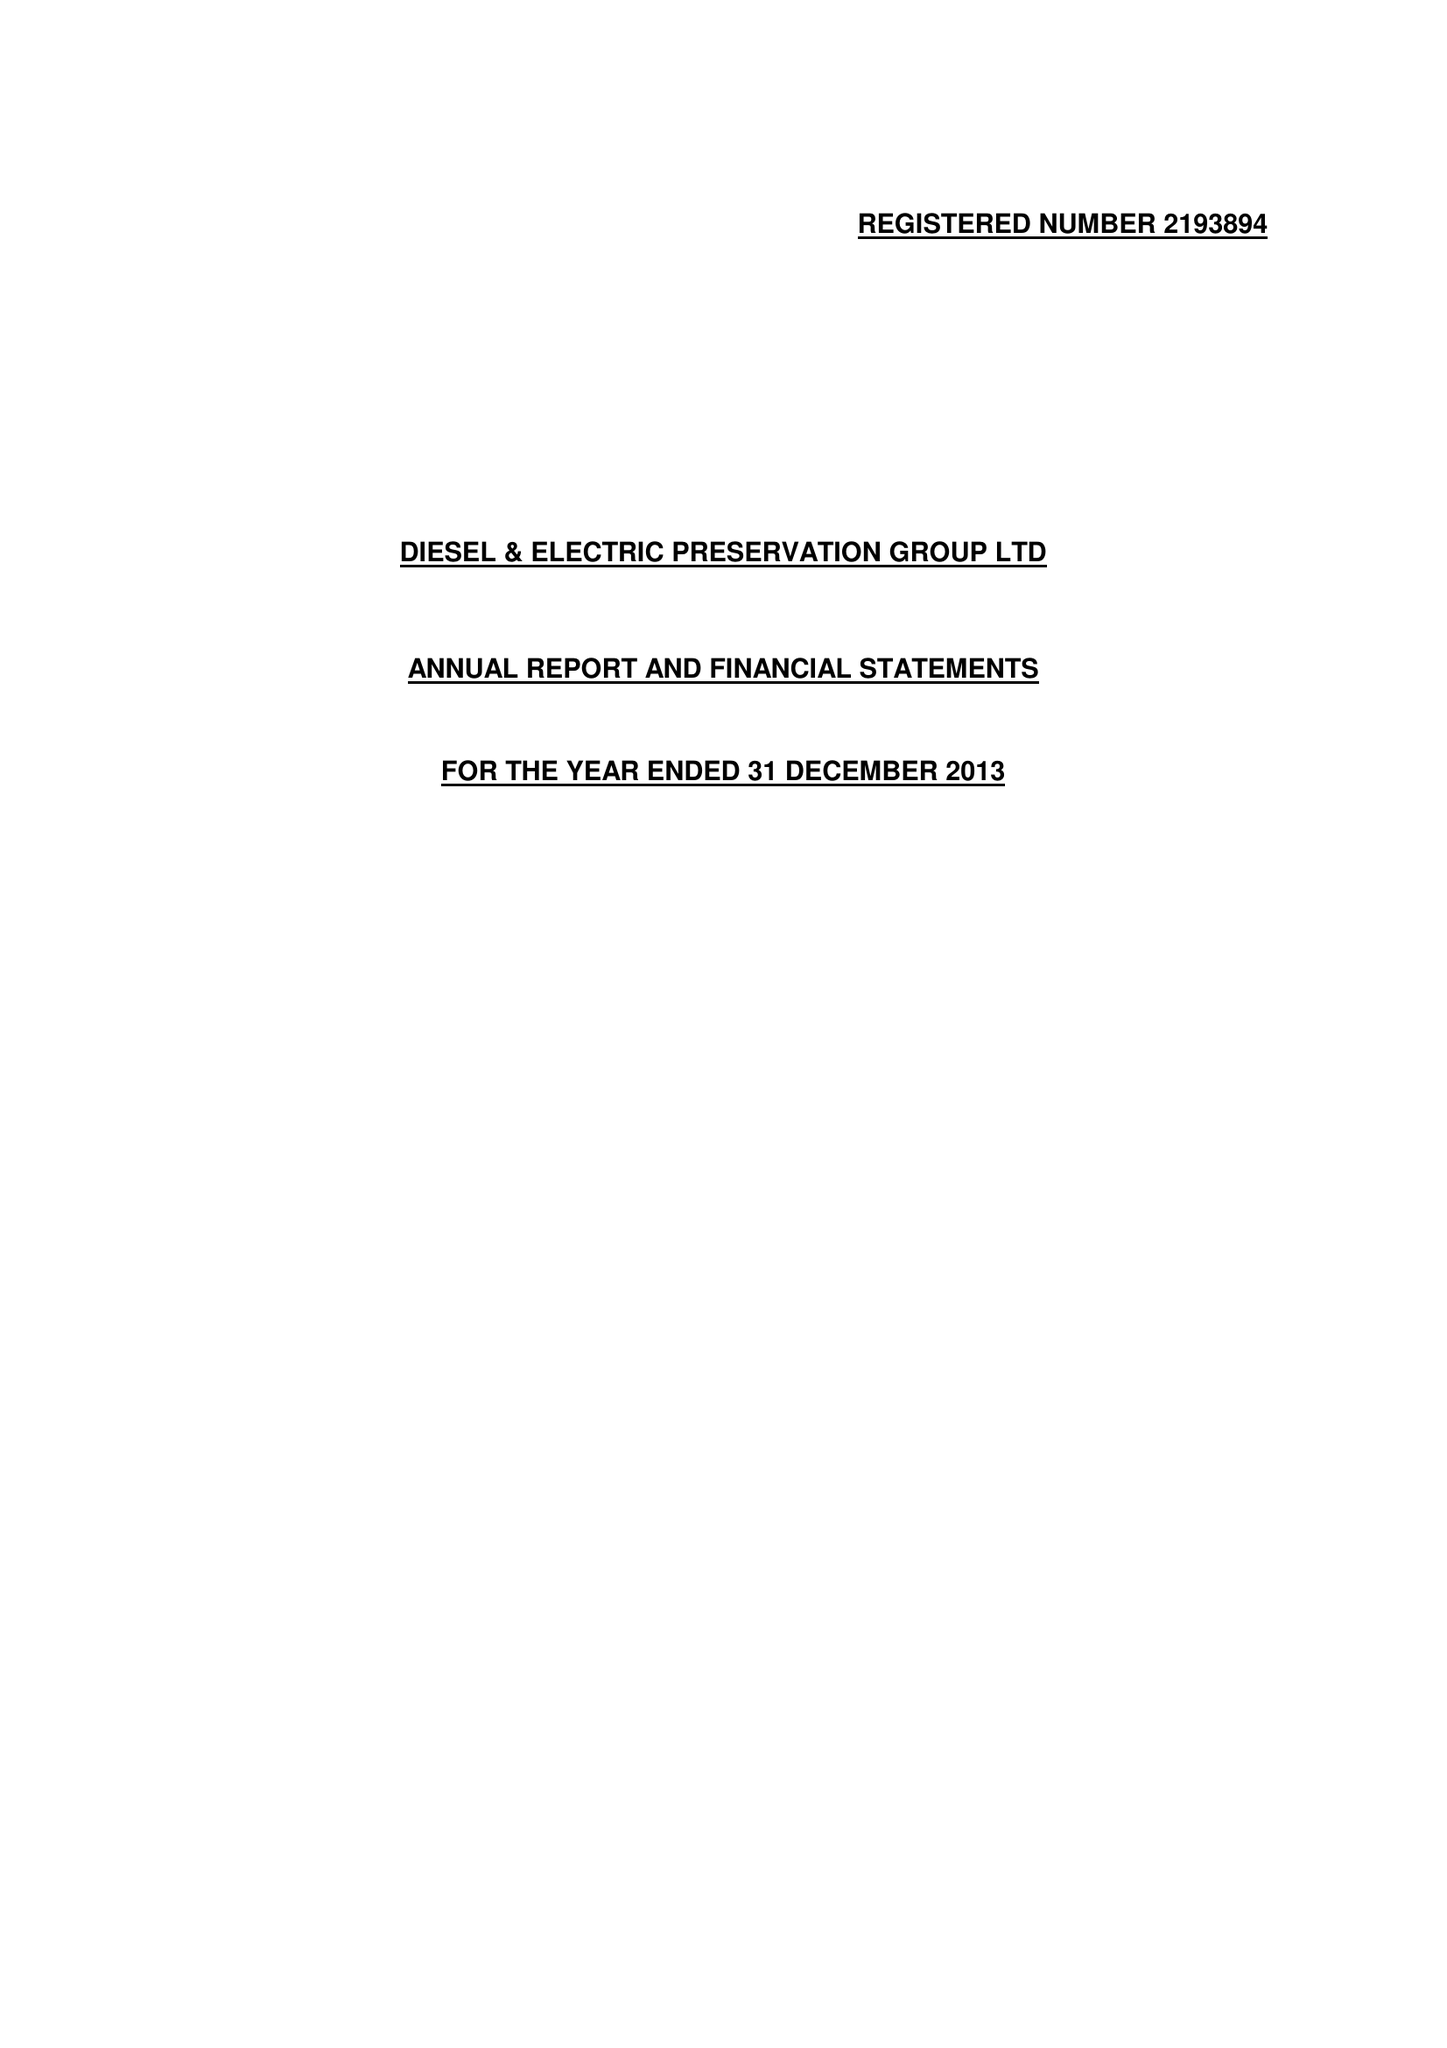What is the value for the address__street_line?
Answer the question using a single word or phrase. None 